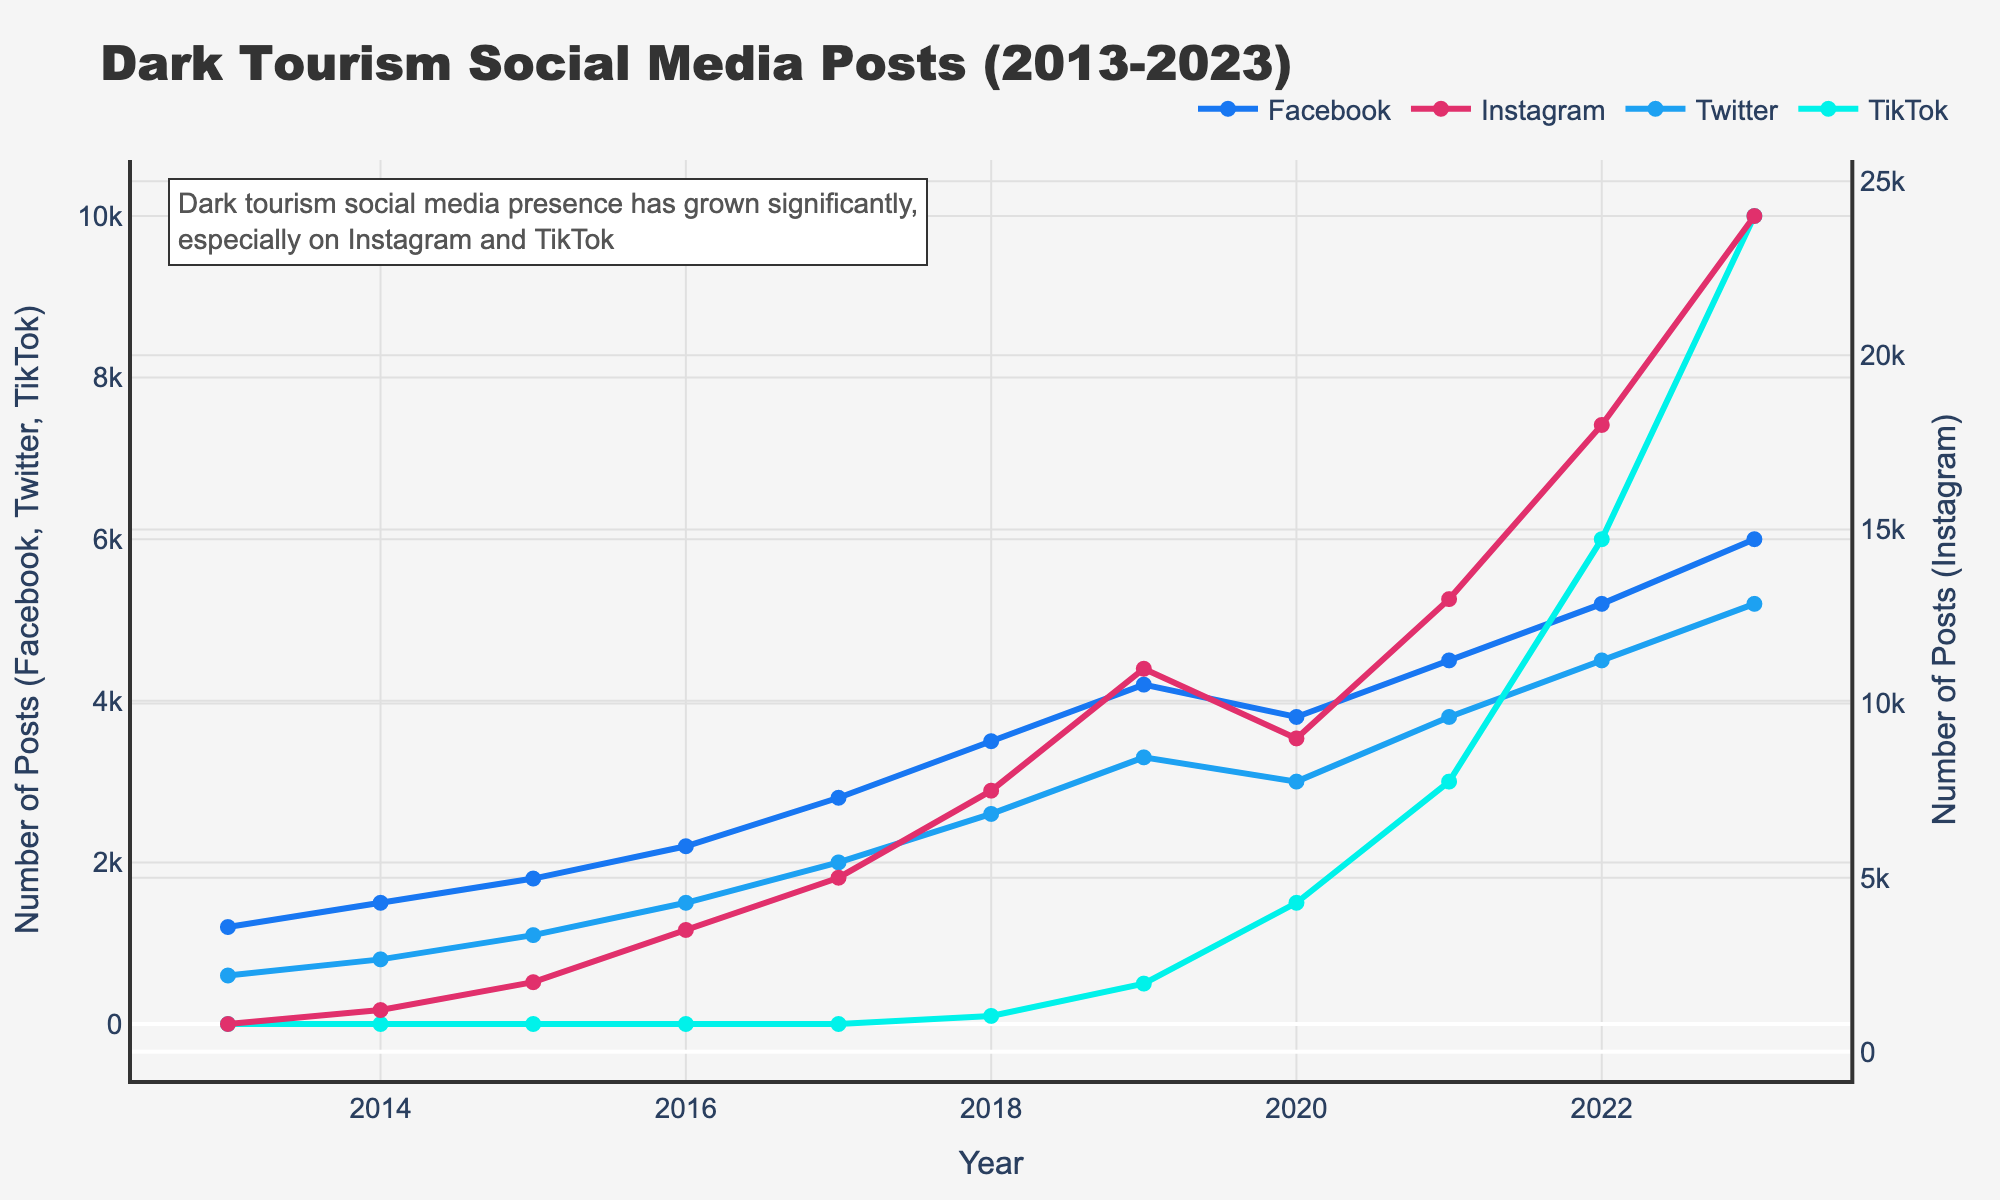Which platform had the highest number of posts in 2023? Refer to the rightmost data points on each curve in the chart. The platform with the highest endpoint is Instagram.
Answer: Instagram How does the growth in posts on TikTok from 2020 to 2023 compare to the growth on Twitter over the same period? Measure the difference between the 2023 and 2020 data points for both TikTok and Twitter. For TikTok, the posts grew from 1500 to 10000, a growth of 8500 posts. For Twitter, the posts grew from 3000 to 5200, a growth of 2200 posts.
Answer: TikTok has a higher growth Which year did Instagram surpass 10000 posts, and what was the value? Locate the point on the Instagram curve that first goes above 10000. In 2019, the Instagram posts are above 10000.
Answer: 2019, 11000 What is the total number of posts on all platforms in 2018? Sum the data points for each platform for the year 2018: Facebook (3500) + Instagram (7500) + Twitter (2600) + TikTok (100) = 13700.
Answer: 13700 Which platform showed the steepest increase in posts between 2017 and 2018, and by how much? Calculate the difference between 2018 and 2017 data points for each platform. Facebook: 3500-2800 = 700, Instagram: 7500-5000 = 2500, Twitter: 2600-2000 = 600, TikTok: 100-0 = 100. The largest increase is on Instagram.
Answer: Instagram, 2500 In which year did TikTok first register posts, and how many did it have? Examine the TikTok curve for the first visible data point: it begins in 2018 with 100 posts.
Answer: 2018, 100 Compare the total posts for Instagram and Twitter in 2023. Which platform had more, and by how much? Identify the 2023 data points: Instagram (24000) and Twitter (5200). Subtract the Twitter value from the Instagram value: 24000 - 5200 = 18800.
Answer: Instagram, 18800 How did the number of Facebook posts change from 2019 to 2020? Locate the data points for Facebook in 2019 and 2020 and find the difference: 4200 - 3800 = 400.
Answer: Decreased by 400 What was the trend for the number of Instagram posts between 2016 and 2017, and how significant was the change? Identify the 2016 and 2017 data points for Instagram and calculate the difference: 5000 - 3500 = 1500.
Answer: Steady increase, 1500 Which social media platform had the least number of posts in 2014, and how many were there? Refer to the data points for 2014 across all platforms. The platform with the lowest number is Twitter with 800 posts.
Answer: Twitter, 800 